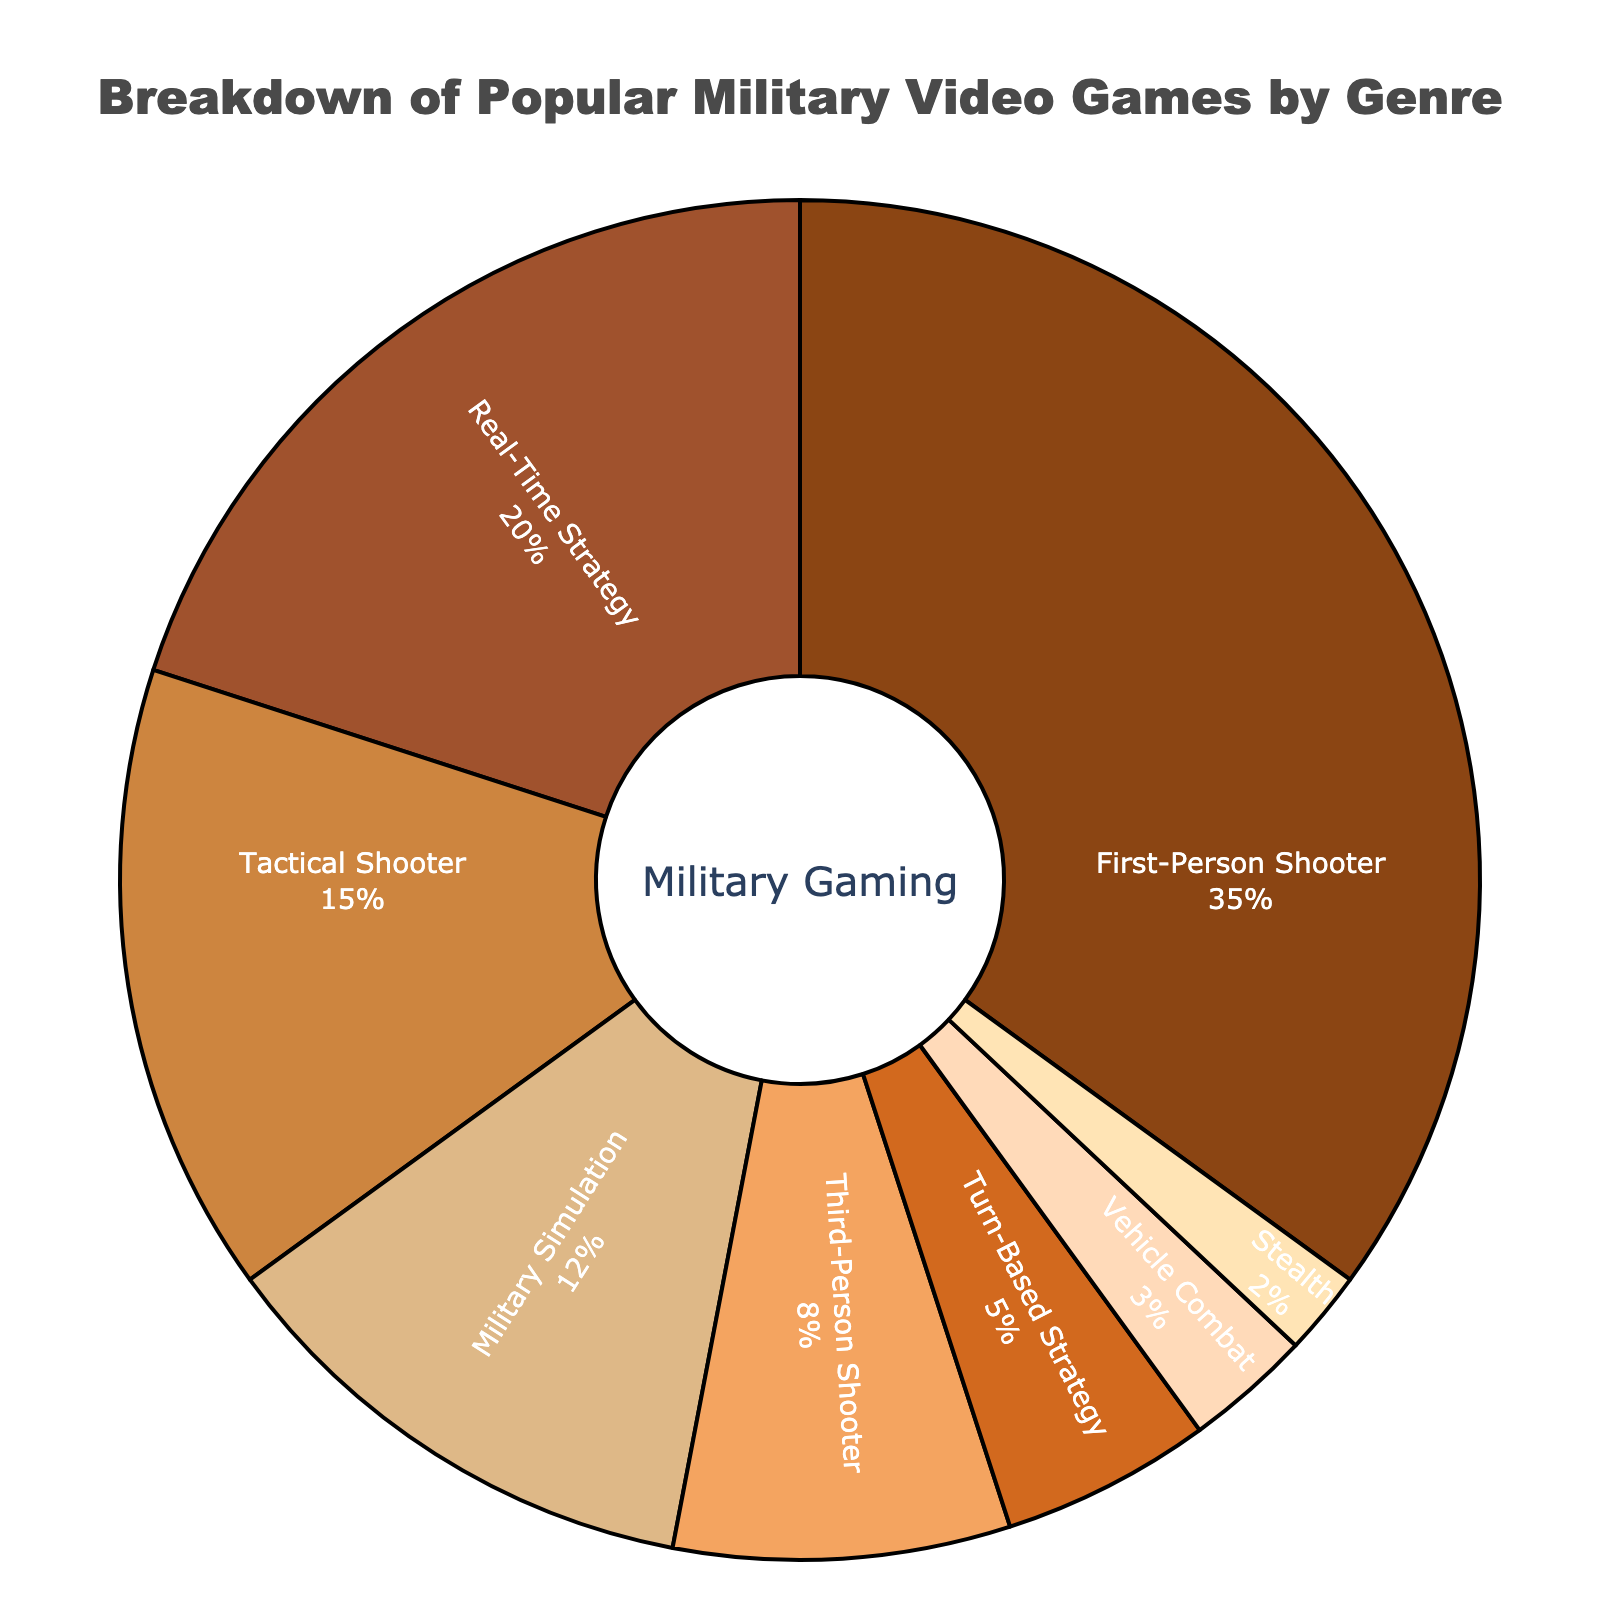what is the most popular genre among military video games? By observing the pie chart, the slice labeled "First-Person Shooter" occupies the largest portion of the circle with 35%, indicating it is the most popular genre.
Answer: First-Person Shooter how does the popularity of Real-Time Strategy games compare to that of Turn-Based Strategy games? By looking at the percentages in the pie chart, Real-Time Strategy comprises 20% while Turn-Based Strategy is 5%. Since 20% is greater than 5%, Real-Time Strategy games are more popular.
Answer: Real-Time Strategy is more popular which genre has a higher proportion, Military Simulation or Third-Person Shooter? The pie chart shows Military Simulation at 12% and Third-Person Shooter at 8%. Since 12% is greater than 8%, Military Simulation has a higher proportion.
Answer: Military Simulation how do Tactical Shooter games compare visually to other genres in terms of the pie slice's size? The Tactical Shooter genre occupies a significant, but not the largest, portion of the pie chart at 15%. Visually, its slice is smaller than First-Person Shooter (35%) but larger than most other genres.
Answer: Tactical Shooter is moderately sized are Vehicle Combat and Stealth genres similarly popular? By examining the pie chart, the Vehicle Combat slice is labeled at 3% while Stealth sits at 2%. These percentages indicate they are similarly popular, but Vehicle Combat is slightly more popular with a 1% difference.
Answer: Yes, with Vehicle Combat being slightly more popular what is the combined percentage for First-Person Shooter and Tactical Shooter genres? Add the percentages of First-Person Shooter (35%) and Tactical Shooter (15%) together. 35% + 15% = 50%.
Answer: 50% how much more popular are First-Person Shooters compared to Turn-Based Strategy games? Subtract the percentage of Turn-Based Strategy (5%) from that of First-Person Shooter (35%). 35% - 5% = 30%.
Answer: 30% if a new genre were to be introduced with 10% popularity, how would it rank against the existing genres? Adding a new genre with 10% would place it higher than Third-Person Shooter (8%), Turn-Based Strategy (5%), Vehicle Combat (3%), and Stealth (2%), but lower than Military Simulation (12%), Tactical Shooter (15%), Real-Time Strategy (20%), and First-Person Shooter (35%).
Answer: It would rank 5th what is the proportion of genres that are not first-person shooters combined? Subtract the percentage of First-Person Shooter (35%) from the total (100%). 100% - 35% = 65%.
Answer: 65% is the percentage of Real-Time Strategy games more than double that of Stealth games? Calculate double the percentage of Stealth (2%). 2% * 2 = 4%. Compare this with Real-Time Strategy (20%). 20% is indeed more than 4%.
Answer: Yes, it is more than double 